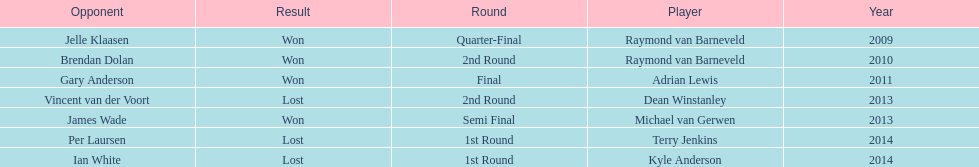Who won the first world darts championship? Raymond van Barneveld. 